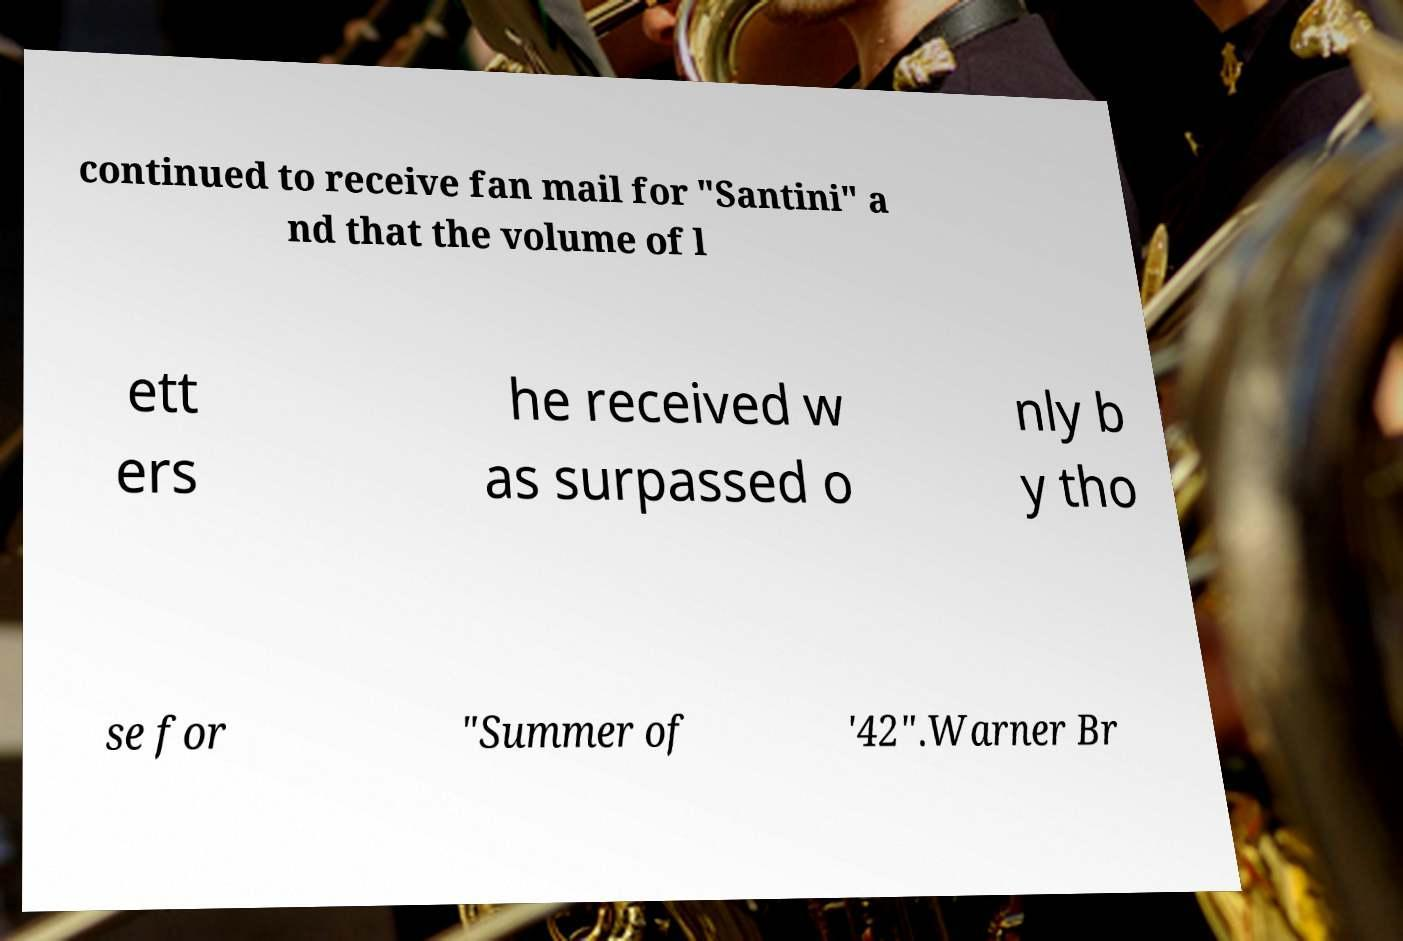Can you accurately transcribe the text from the provided image for me? continued to receive fan mail for "Santini" a nd that the volume of l ett ers he received w as surpassed o nly b y tho se for "Summer of '42".Warner Br 